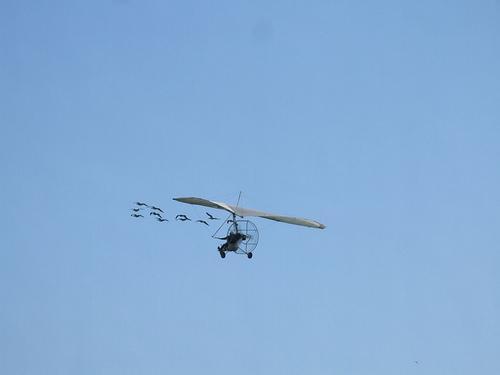How many people are in the picture?
Give a very brief answer. 1. How many propellers are on the machine?
Give a very brief answer. 1. 